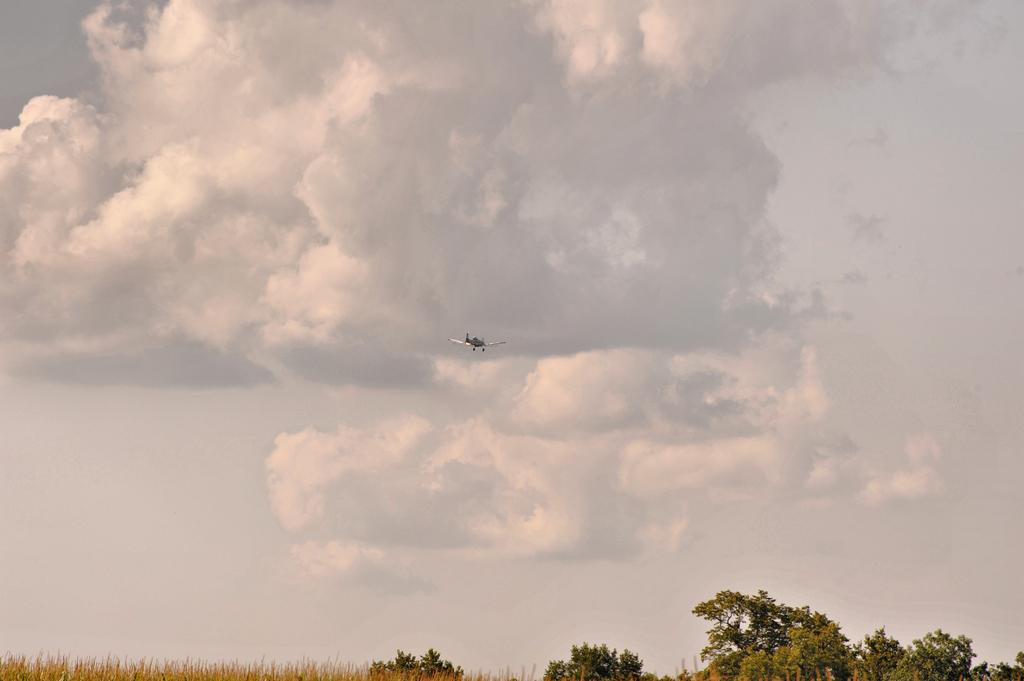What is flying in the sky in the image? There is an airplane flying in the sky in the image. What can be seen in the background of the image? The sky is visible in the background of the image. What is present in the sky? Clouds are present in the sky. What is visible at the bottom of the picture? Grass and trees are visible at the bottom of the picture. What book is the airplane reading while flying in the image? There is no book present in the image, and airplanes do not read books. 